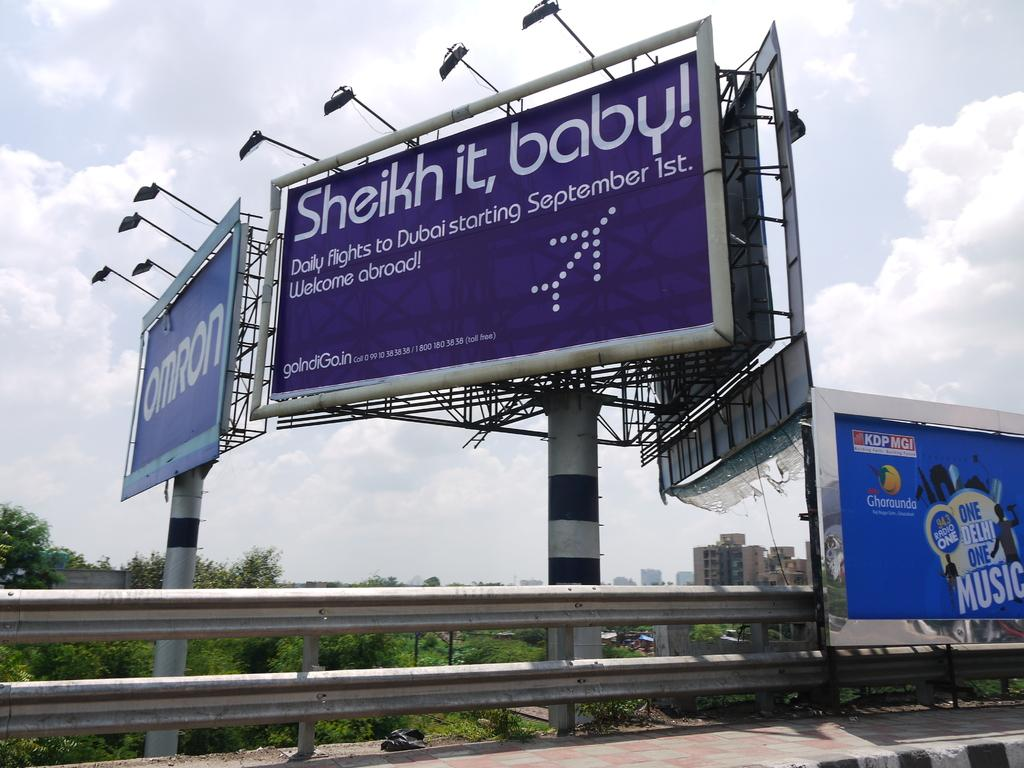<image>
Describe the image concisely. a billboard that says 'sheikh it, baby!' on it 